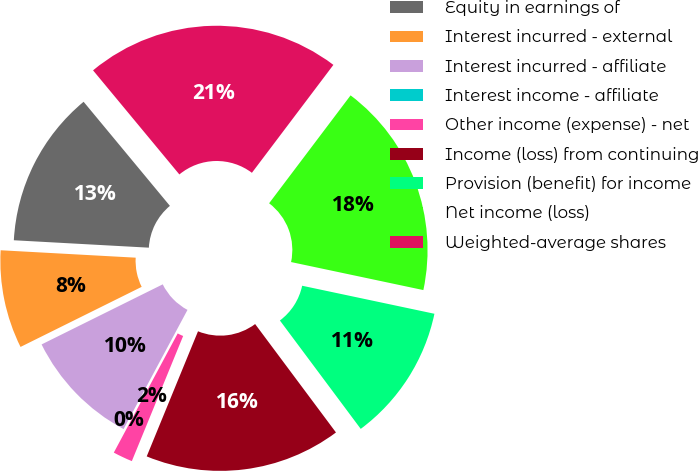Convert chart to OTSL. <chart><loc_0><loc_0><loc_500><loc_500><pie_chart><fcel>Equity in earnings of<fcel>Interest incurred - external<fcel>Interest incurred - affiliate<fcel>Interest income - affiliate<fcel>Other income (expense) - net<fcel>Income (loss) from continuing<fcel>Provision (benefit) for income<fcel>Net income (loss)<fcel>Weighted-average shares<nl><fcel>13.11%<fcel>8.2%<fcel>9.84%<fcel>0.0%<fcel>1.64%<fcel>16.39%<fcel>11.48%<fcel>18.03%<fcel>21.31%<nl></chart> 